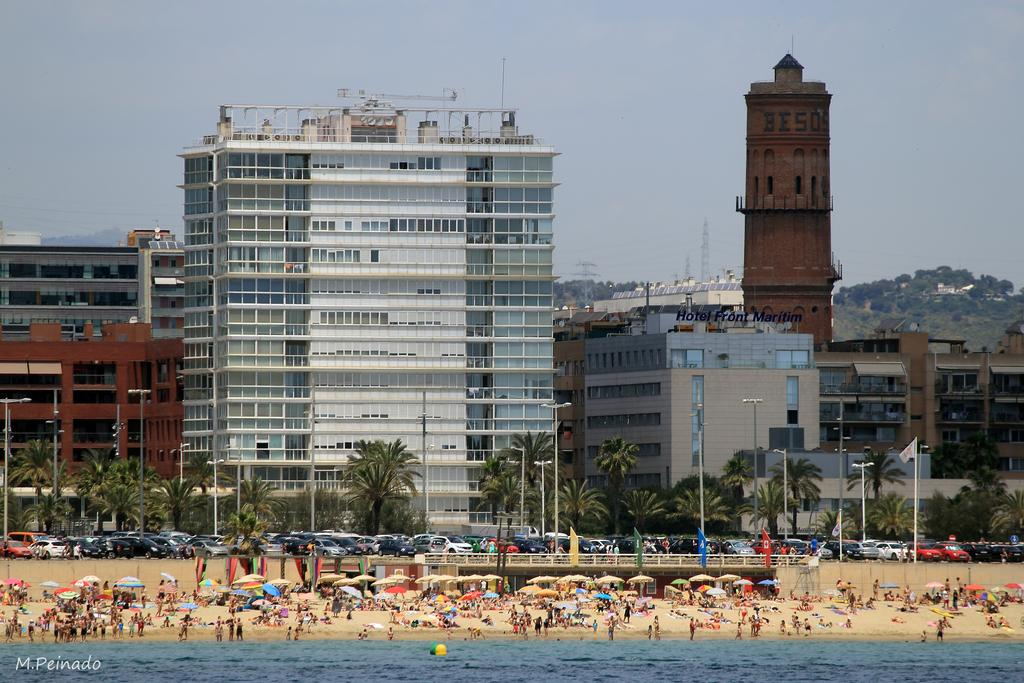What is the primary element visible in the image? There is water in the image. What objects can be seen in the image that might provide shade or protection from the rain? There are umbrellas in the image. What structures are present in the image that might be used for support or signage? There are poles in the image. What type of vegetation is visible in the image? There are trees in the image. What type of transportation is present in the image? There are vehicles in the image. Can you describe the group of people in the image? There is a group of people in the image. What can be seen in the background of the image? There are buildings and the sky visible in the background of the image. What is the rate of the daughter's hate for the person in the image? There is no mention of a daughter or hate in the image, so it is not possible to determine a rate. 